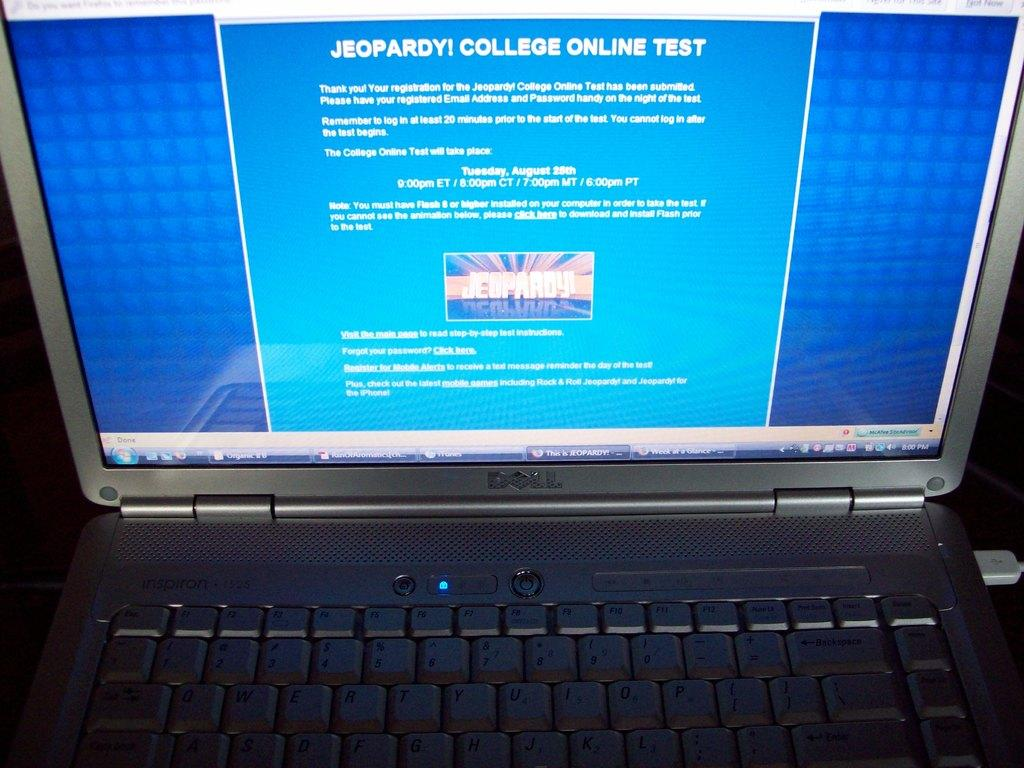<image>
Describe the image concisely. An open silver laptop with a black keyboard made by Dell. 